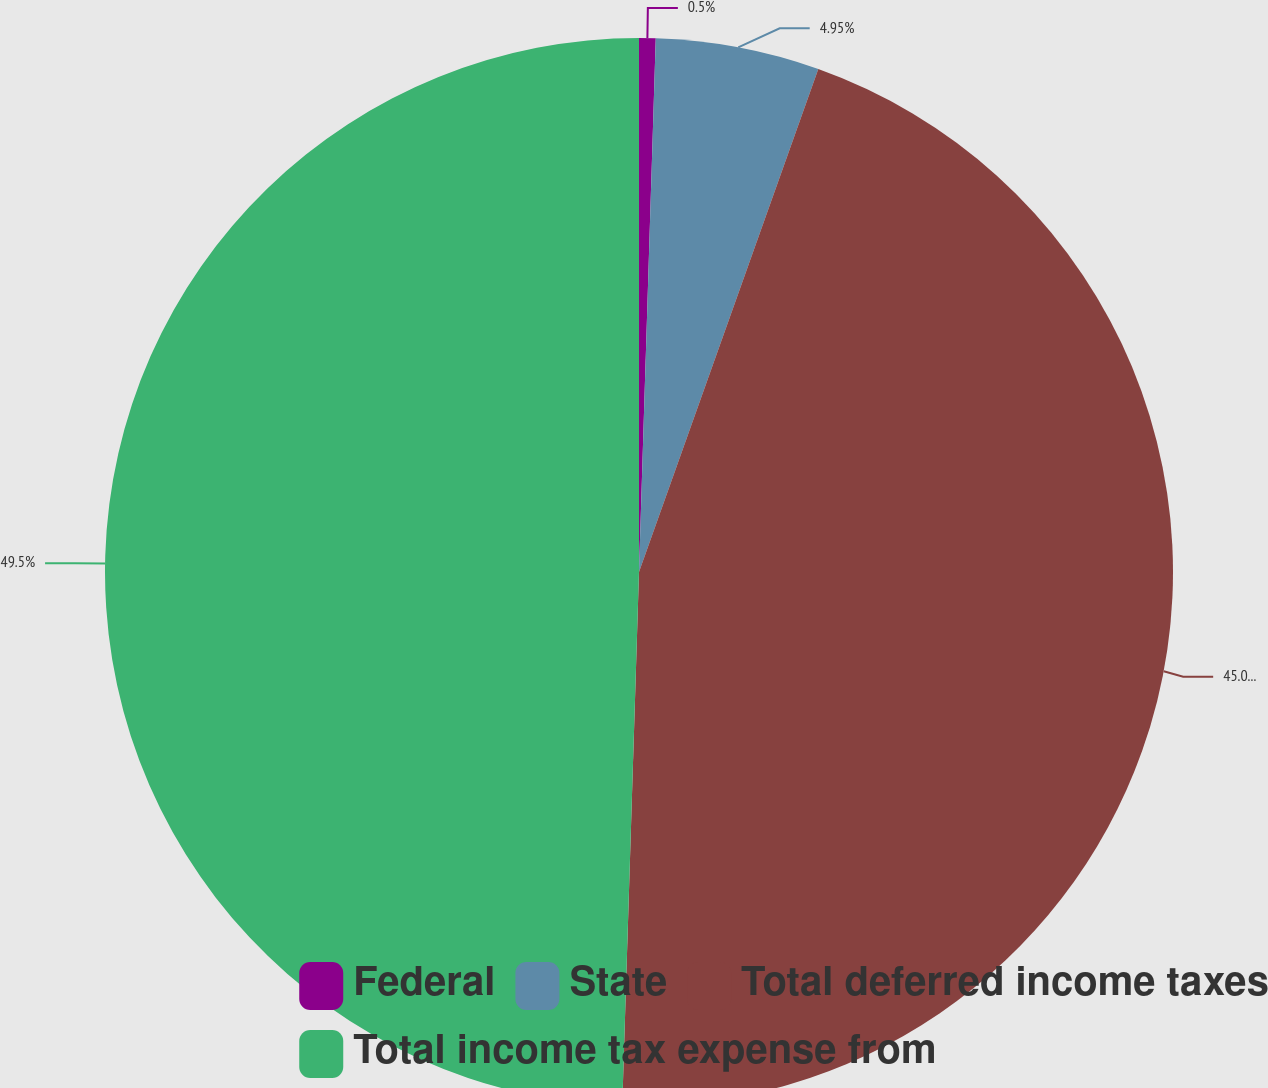Convert chart to OTSL. <chart><loc_0><loc_0><loc_500><loc_500><pie_chart><fcel>Federal<fcel>State<fcel>Total deferred income taxes<fcel>Total income tax expense from<nl><fcel>0.5%<fcel>4.95%<fcel>45.05%<fcel>49.5%<nl></chart> 